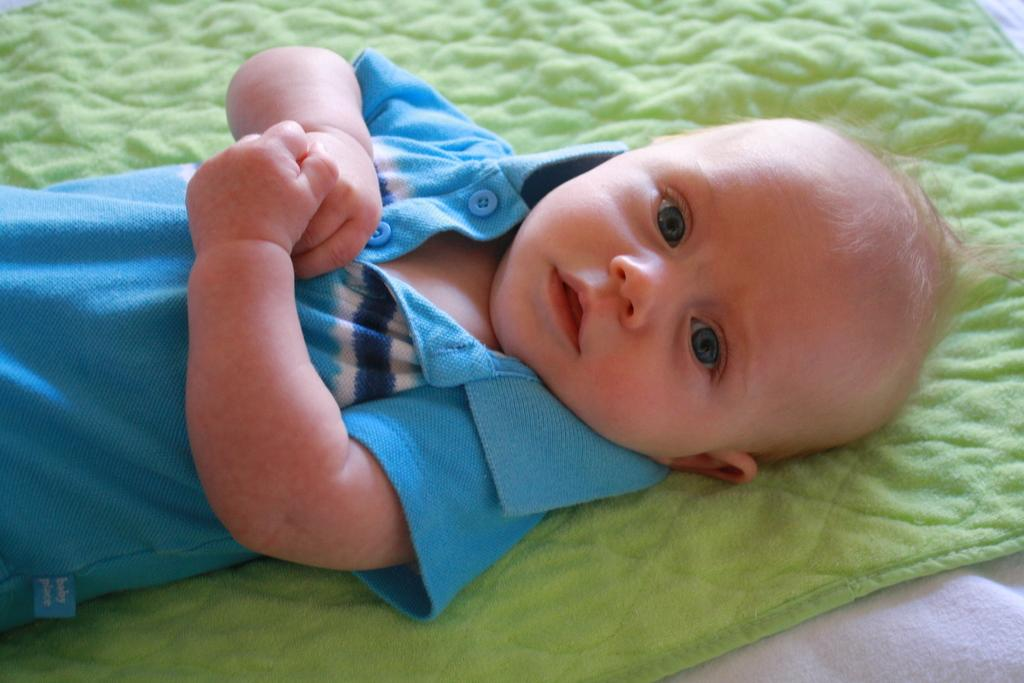What is the main subject of the image? There is a baby in the image. What is the baby doing in the image? The baby is sleeping. What color is the cloth the baby is lying on? The baby is on a green color cloth. What color is the baby's t-shirt? The baby is wearing a blue color t-shirt. What color is the cloth at the bottom of the image? There is a white color cloth at the bottom. How many branches can be seen in the image? There are no branches visible in the image; it features a baby sleeping on a green cloth. What time of day is it in the image, based on the hour? The provided facts do not mention the time of day or any specific hour, so it cannot be determined from the image. 